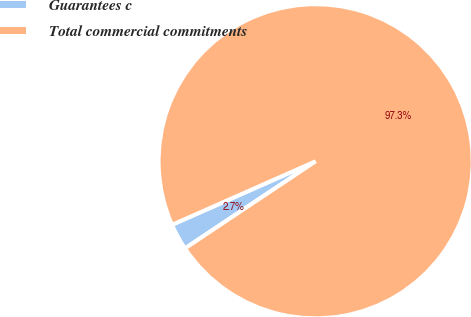Convert chart. <chart><loc_0><loc_0><loc_500><loc_500><pie_chart><fcel>Guarantees c<fcel>Total commercial commitments<nl><fcel>2.73%<fcel>97.27%<nl></chart> 